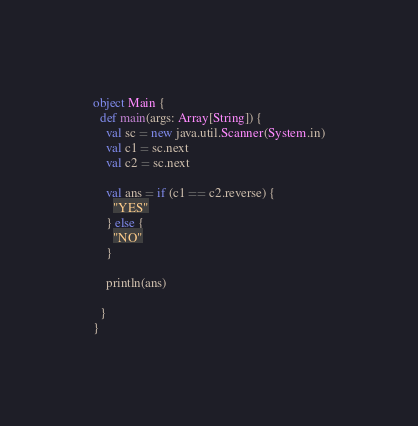<code> <loc_0><loc_0><loc_500><loc_500><_Scala_>object Main {
  def main(args: Array[String]) {
    val sc = new java.util.Scanner(System.in)
    val c1 = sc.next
    val c2 = sc.next

    val ans = if (c1 == c2.reverse) {
      "YES"
    } else {
      "NO"
    }

    println(ans)

  }
}
</code> 